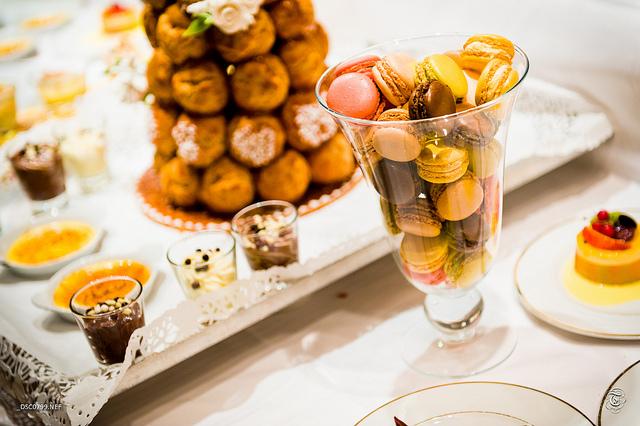Would the items in this photo make a healthy meal?
Write a very short answer. No. What are the sweets in the glass called?
Concise answer only. Macaroons. Is there a glass filled with candy in the photo?
Concise answer only. Yes. 